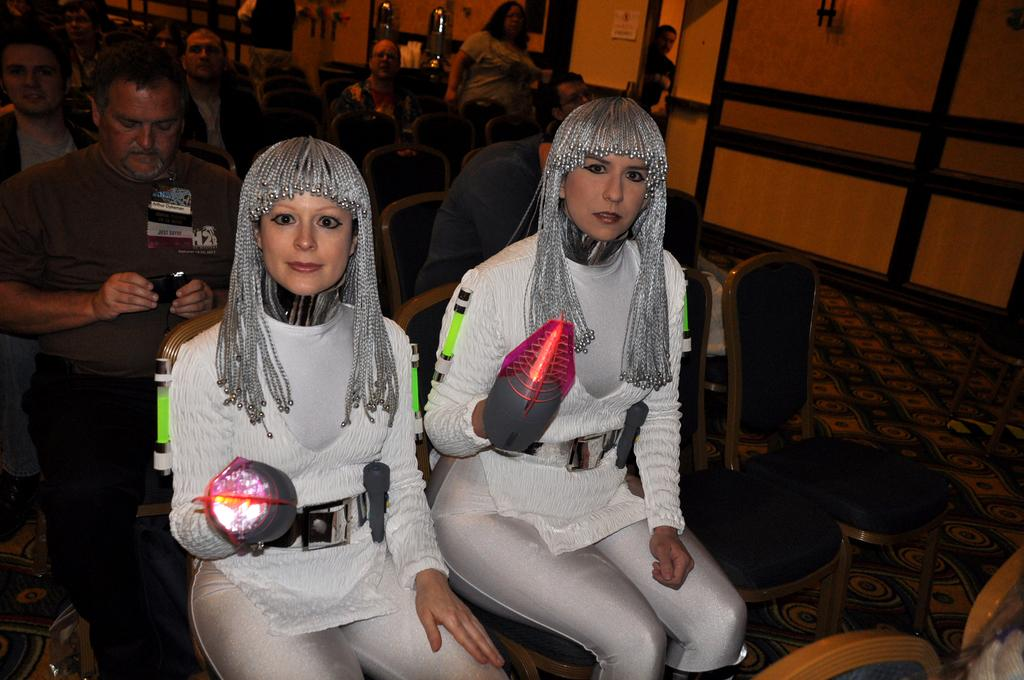What are the people in the image doing? People are sitting on chairs in the image. What is on the floor? There is a carpet on the floor in the image. What is the man holding? A man is holding an object in the image. Where is the woman positioned in relation to the others? A woman is standing far away from the others in the image. What type of thumb can be seen in the image? There is no thumb present in the image. Is the scene taking place during the morning? The time of day is not mentioned in the provided facts, so it cannot be determined from the image. 